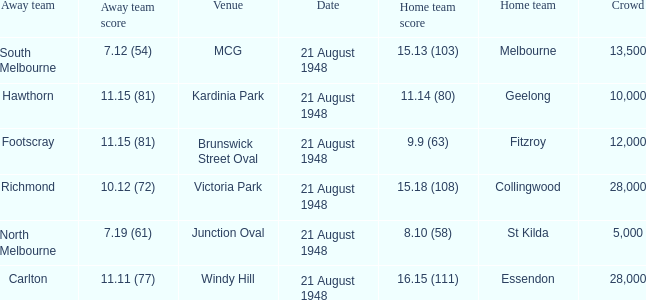When north melbourne is the away team, what is the score of the home team? 8.10 (58). 